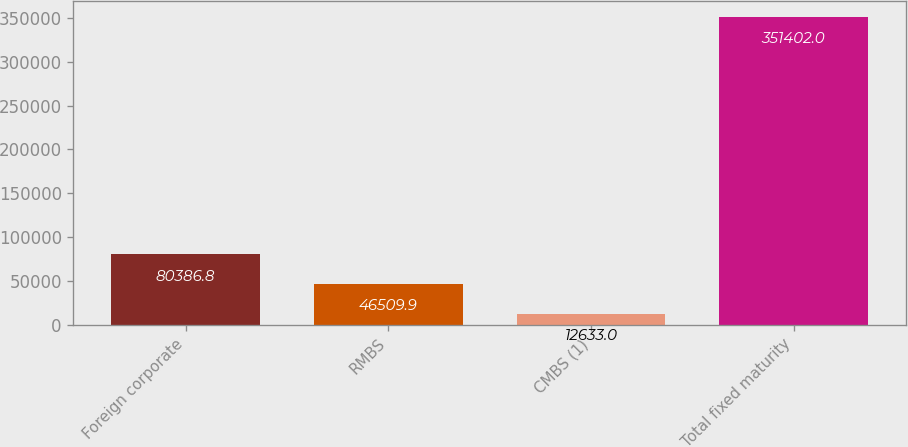Convert chart. <chart><loc_0><loc_0><loc_500><loc_500><bar_chart><fcel>Foreign corporate<fcel>RMBS<fcel>CMBS (1)<fcel>Total fixed maturity<nl><fcel>80386.8<fcel>46509.9<fcel>12633<fcel>351402<nl></chart> 